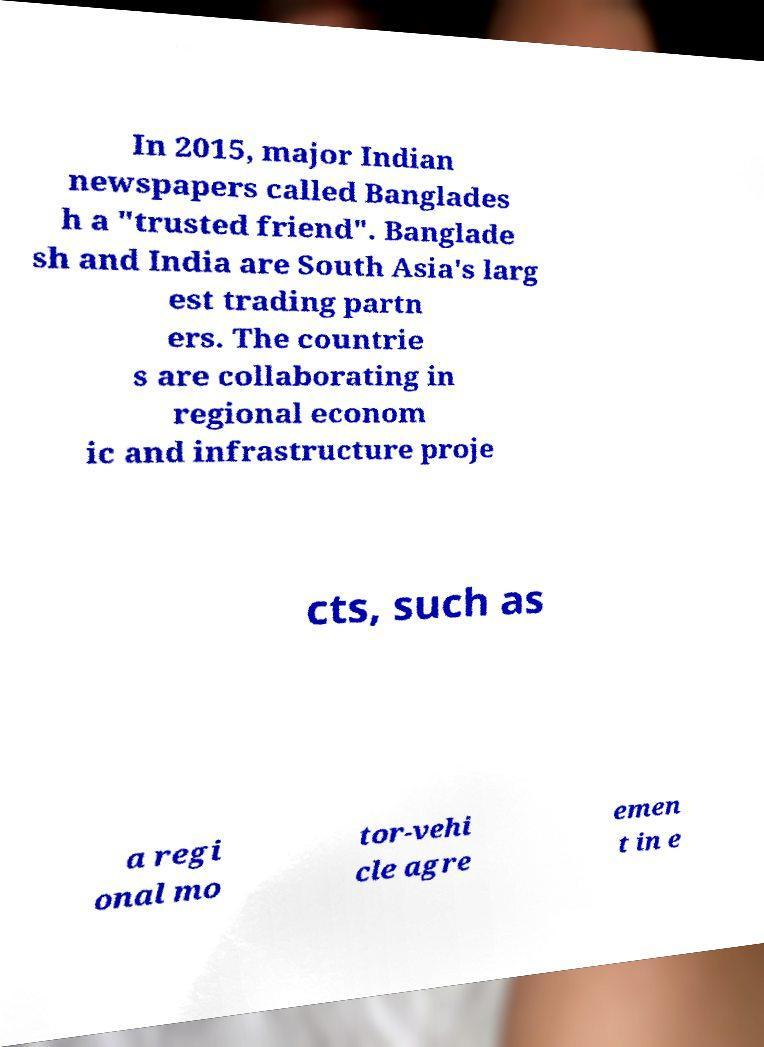Please identify and transcribe the text found in this image. In 2015, major Indian newspapers called Banglades h a "trusted friend". Banglade sh and India are South Asia's larg est trading partn ers. The countrie s are collaborating in regional econom ic and infrastructure proje cts, such as a regi onal mo tor-vehi cle agre emen t in e 